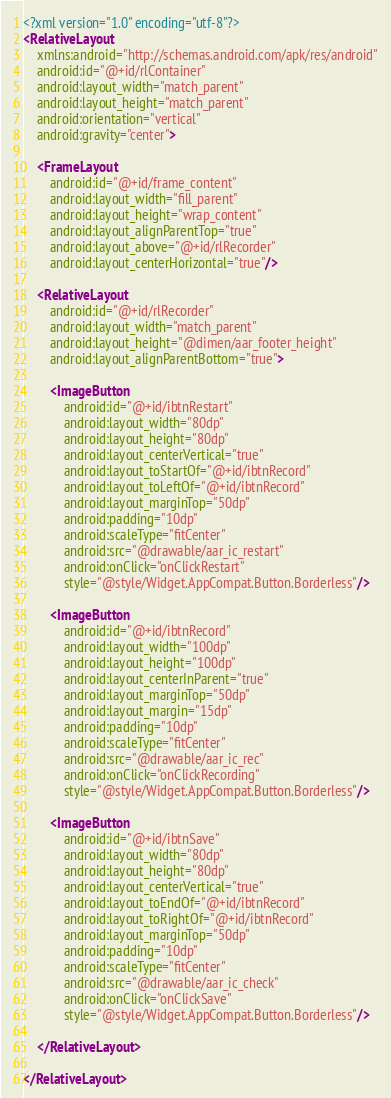Convert code to text. <code><loc_0><loc_0><loc_500><loc_500><_XML_><?xml version="1.0" encoding="utf-8"?>
<RelativeLayout
    xmlns:android="http://schemas.android.com/apk/res/android"
    android:id="@+id/rlContainer"
    android:layout_width="match_parent"
    android:layout_height="match_parent"
    android:orientation="vertical"
    android:gravity="center">

    <FrameLayout
        android:id="@+id/frame_content"
        android:layout_width="fill_parent"
        android:layout_height="wrap_content"
        android:layout_alignParentTop="true"
        android:layout_above="@+id/rlRecorder"
        android:layout_centerHorizontal="true"/>

    <RelativeLayout
        android:id="@+id/rlRecorder"
        android:layout_width="match_parent"
        android:layout_height="@dimen/aar_footer_height"
        android:layout_alignParentBottom="true">

        <ImageButton
            android:id="@+id/ibtnRestart"
            android:layout_width="80dp"
            android:layout_height="80dp"
            android:layout_centerVertical="true"
            android:layout_toStartOf="@+id/ibtnRecord"
            android:layout_toLeftOf="@+id/ibtnRecord"
            android:layout_marginTop="50dp"
            android:padding="10dp"
            android:scaleType="fitCenter"
            android:src="@drawable/aar_ic_restart"
            android:onClick="onClickRestart"
            style="@style/Widget.AppCompat.Button.Borderless"/>

        <ImageButton
            android:id="@+id/ibtnRecord"
            android:layout_width="100dp"
            android:layout_height="100dp"
            android:layout_centerInParent="true"
            android:layout_marginTop="50dp"
            android:layout_margin="15dp"
            android:padding="10dp"
            android:scaleType="fitCenter"
            android:src="@drawable/aar_ic_rec"
            android:onClick="onClickRecording"
            style="@style/Widget.AppCompat.Button.Borderless"/>

        <ImageButton
            android:id="@+id/ibtnSave"
            android:layout_width="80dp"
            android:layout_height="80dp"
            android:layout_centerVertical="true"
            android:layout_toEndOf="@+id/ibtnRecord"
            android:layout_toRightOf="@+id/ibtnRecord"
            android:layout_marginTop="50dp"
            android:padding="10dp"
            android:scaleType="fitCenter"
            android:src="@drawable/aar_ic_check"
            android:onClick="onClickSave"
            style="@style/Widget.AppCompat.Button.Borderless"/>

    </RelativeLayout>

</RelativeLayout></code> 